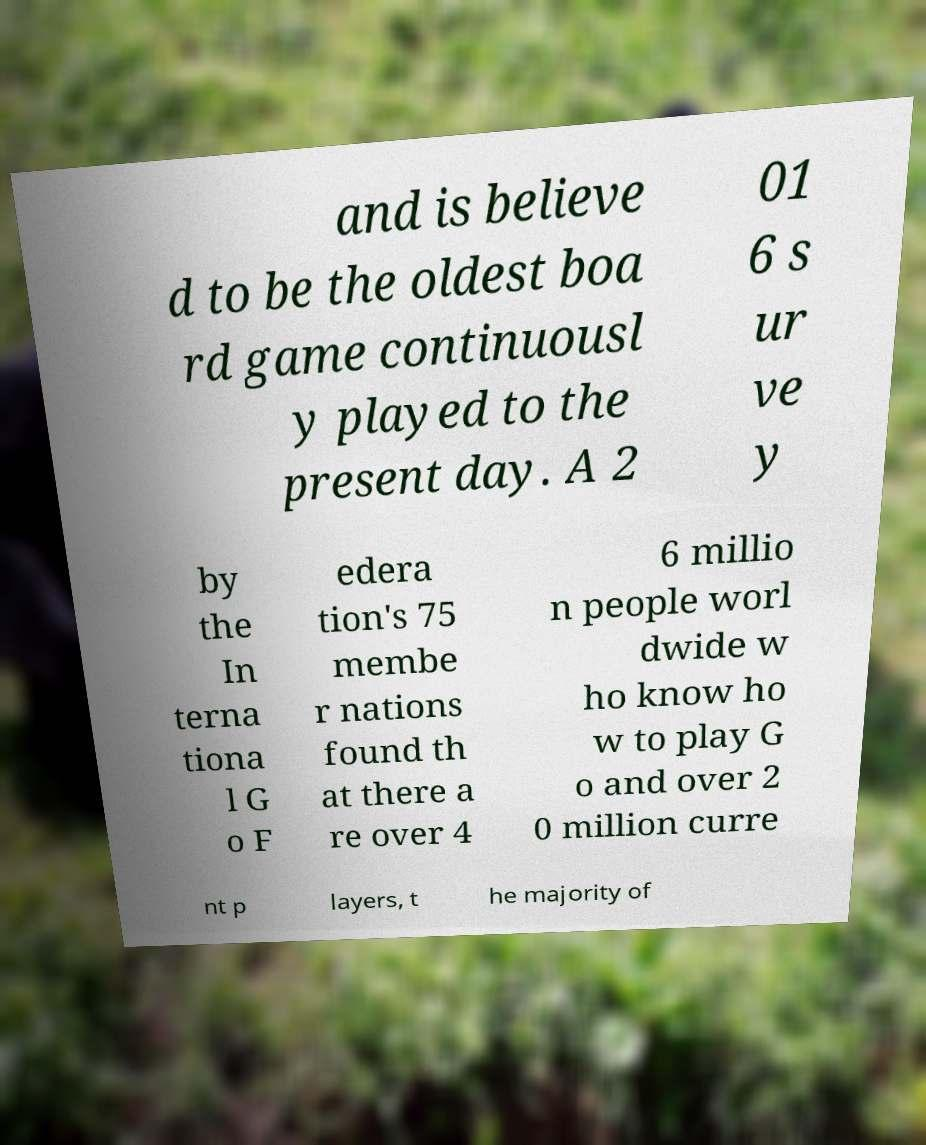Could you extract and type out the text from this image? and is believe d to be the oldest boa rd game continuousl y played to the present day. A 2 01 6 s ur ve y by the In terna tiona l G o F edera tion's 75 membe r nations found th at there a re over 4 6 millio n people worl dwide w ho know ho w to play G o and over 2 0 million curre nt p layers, t he majority of 